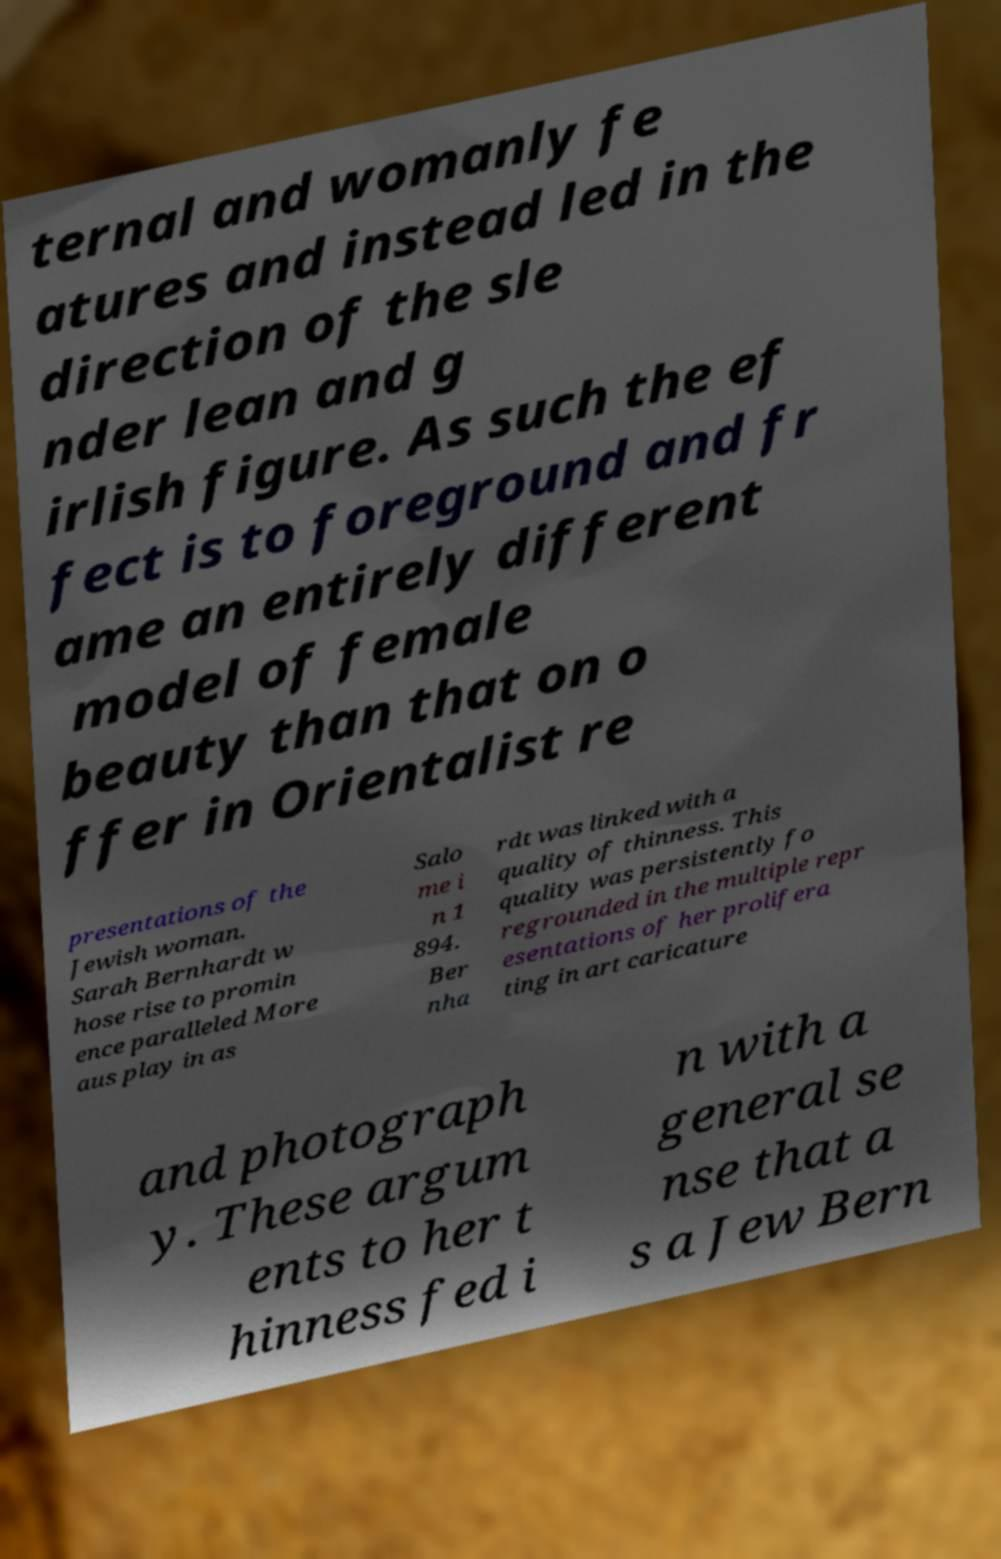Could you assist in decoding the text presented in this image and type it out clearly? ternal and womanly fe atures and instead led in the direction of the sle nder lean and g irlish figure. As such the ef fect is to foreground and fr ame an entirely different model of female beauty than that on o ffer in Orientalist re presentations of the Jewish woman. Sarah Bernhardt w hose rise to promin ence paralleled More aus play in as Salo me i n 1 894. Ber nha rdt was linked with a quality of thinness. This quality was persistently fo regrounded in the multiple repr esentations of her prolifera ting in art caricature and photograph y. These argum ents to her t hinness fed i n with a general se nse that a s a Jew Bern 